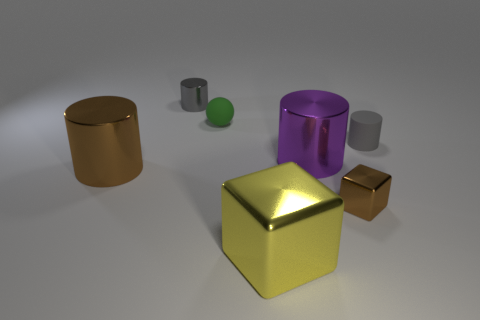Subtract all brown cylinders. How many cylinders are left? 3 Subtract all purple spheres. How many gray cylinders are left? 2 Add 2 tiny balls. How many objects exist? 9 Subtract all brown cylinders. How many cylinders are left? 3 Subtract all cubes. How many objects are left? 5 Add 1 big purple cylinders. How many big purple cylinders exist? 2 Subtract 0 gray balls. How many objects are left? 7 Subtract all red cylinders. Subtract all gray balls. How many cylinders are left? 4 Subtract all gray rubber objects. Subtract all big metal cylinders. How many objects are left? 4 Add 1 yellow objects. How many yellow objects are left? 2 